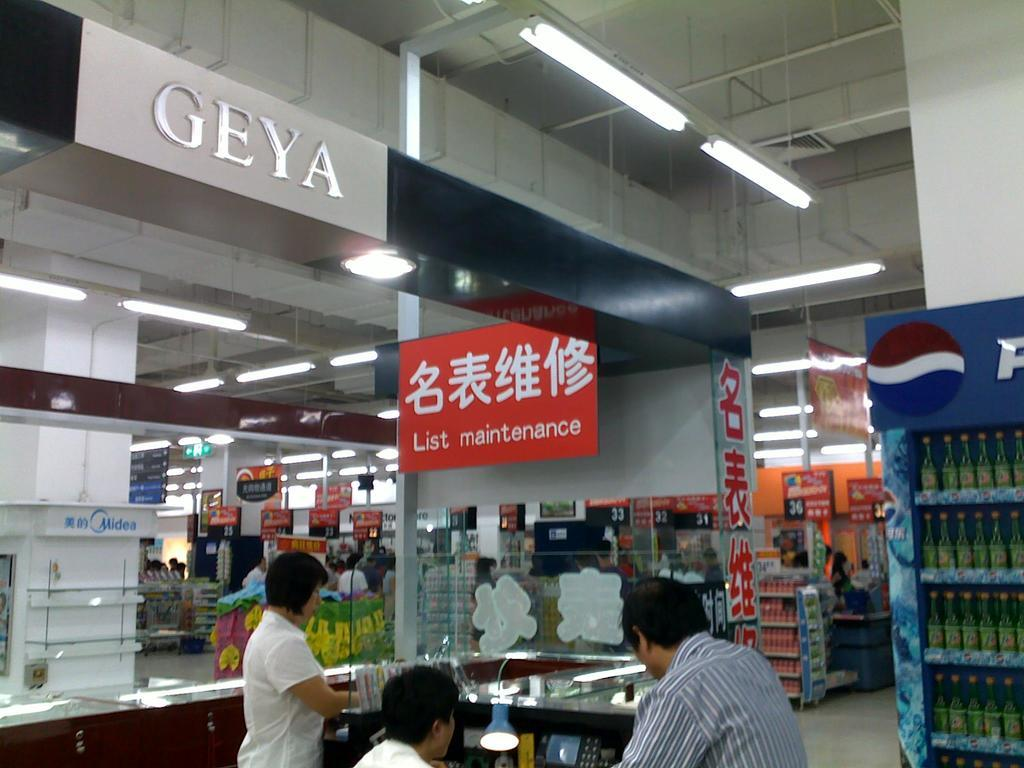Provide a one-sentence caption for the provided image. A man is at a desk in a large store under a sign that said List Maintenance. 